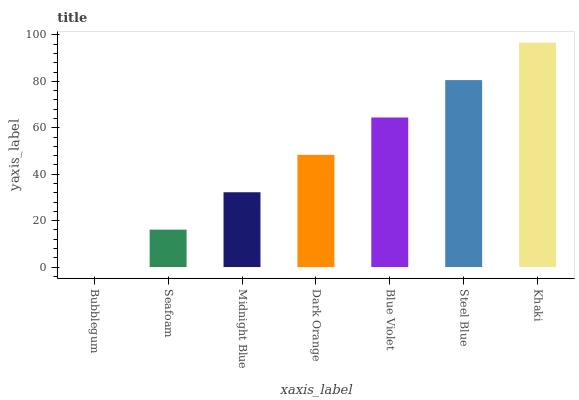Is Bubblegum the minimum?
Answer yes or no. Yes. Is Khaki the maximum?
Answer yes or no. Yes. Is Seafoam the minimum?
Answer yes or no. No. Is Seafoam the maximum?
Answer yes or no. No. Is Seafoam greater than Bubblegum?
Answer yes or no. Yes. Is Bubblegum less than Seafoam?
Answer yes or no. Yes. Is Bubblegum greater than Seafoam?
Answer yes or no. No. Is Seafoam less than Bubblegum?
Answer yes or no. No. Is Dark Orange the high median?
Answer yes or no. Yes. Is Dark Orange the low median?
Answer yes or no. Yes. Is Blue Violet the high median?
Answer yes or no. No. Is Blue Violet the low median?
Answer yes or no. No. 